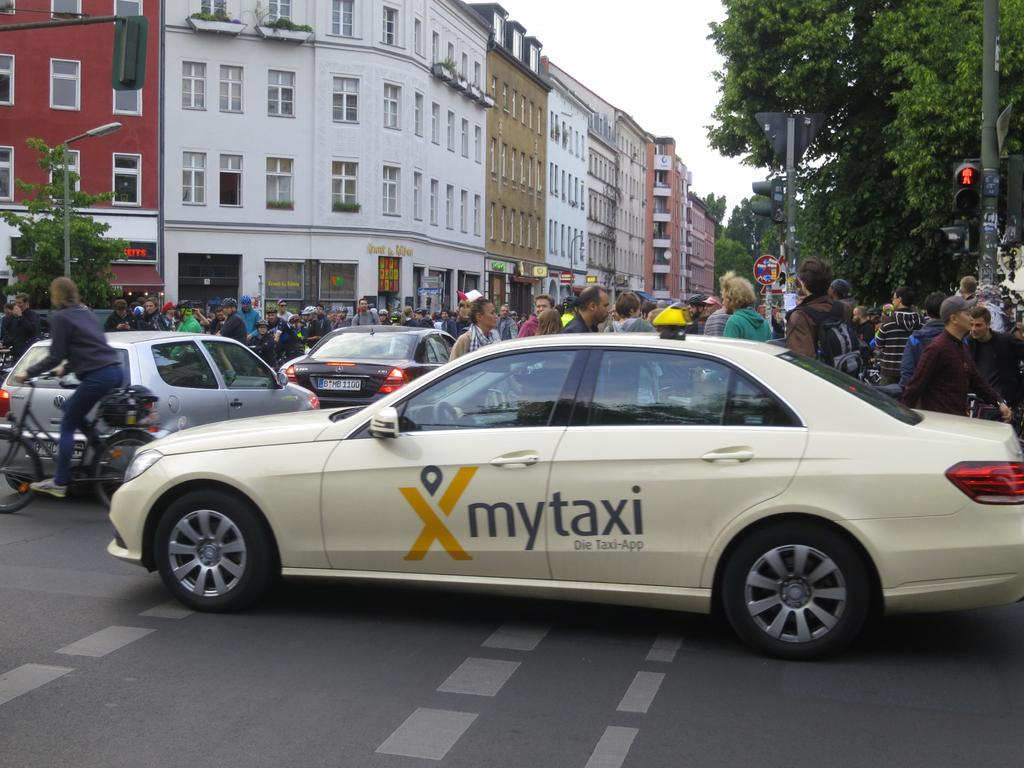<image>
Present a compact description of the photo's key features. A car that says mytaxi is trying to get through a street filled with people 